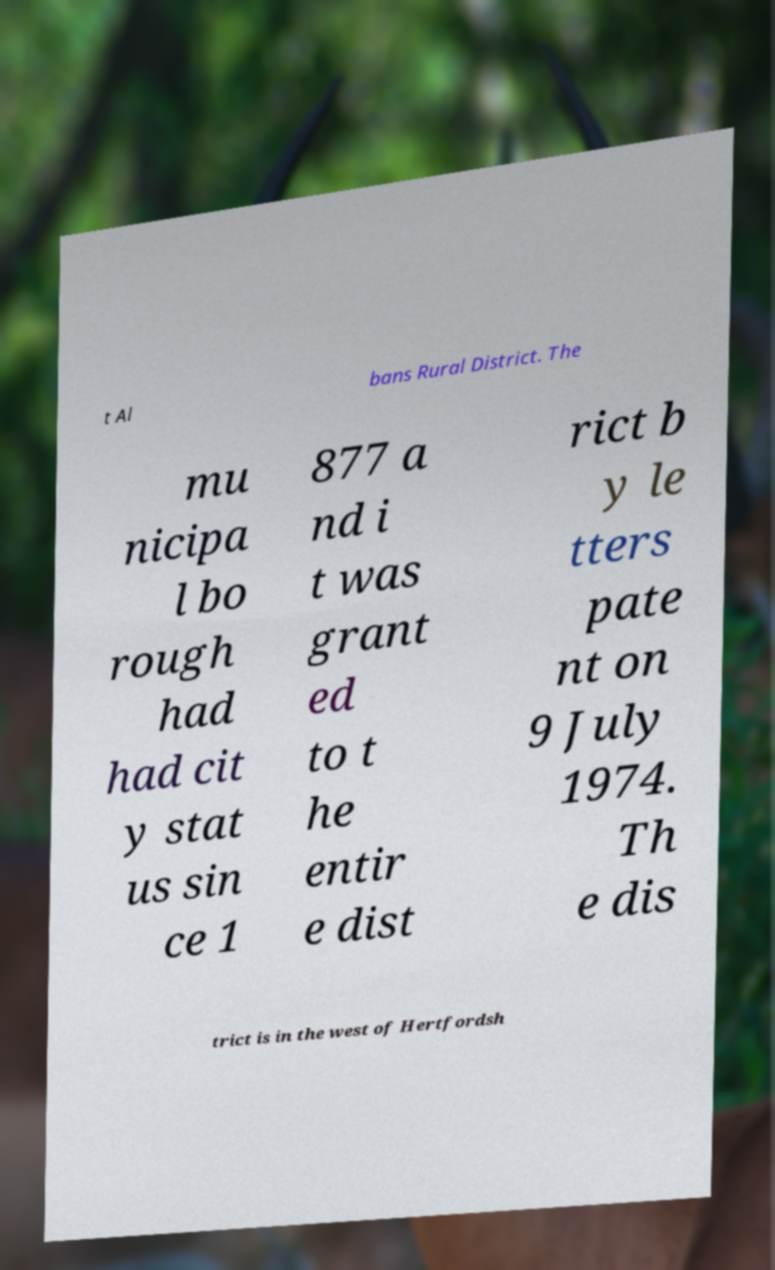What messages or text are displayed in this image? I need them in a readable, typed format. t Al bans Rural District. The mu nicipa l bo rough had had cit y stat us sin ce 1 877 a nd i t was grant ed to t he entir e dist rict b y le tters pate nt on 9 July 1974. Th e dis trict is in the west of Hertfordsh 